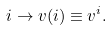<formula> <loc_0><loc_0><loc_500><loc_500>i \rightarrow v ( i ) \equiv v ^ { i } .</formula> 